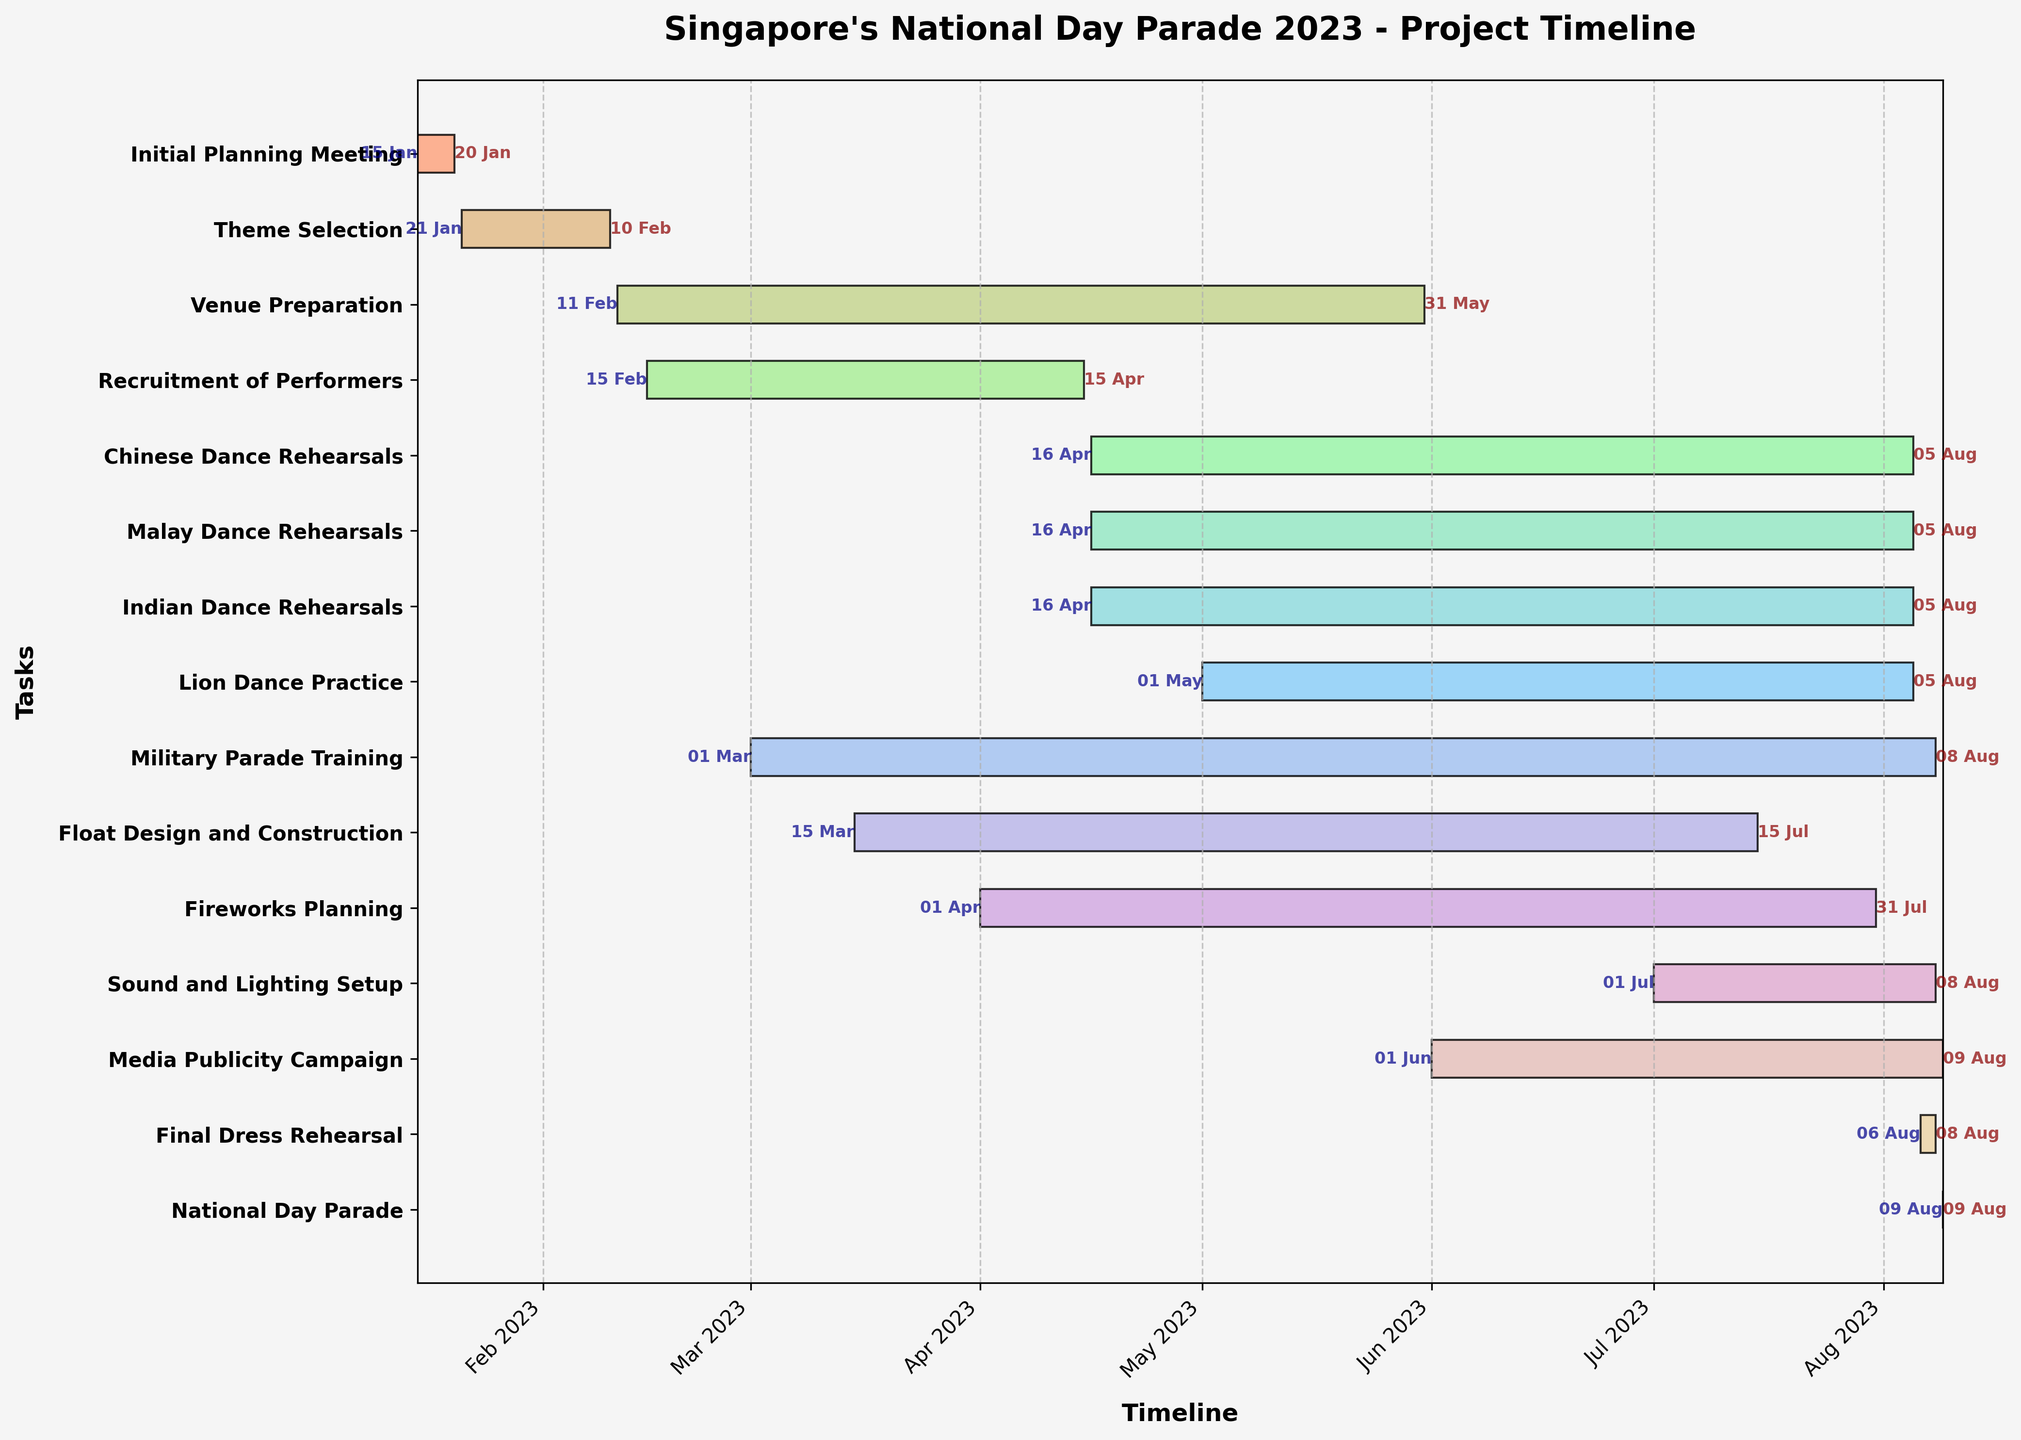What is the title of the Gantt chart? The title is usually displayed at the top of the chart. In this case, it reads "Singapore's National Day Parade 2023 - Project Timeline"
Answer: Singapore's National Day Parade 2023 - Project Timeline When does the Venue Preparation start and end? By looking at the Venue Preparation task on the y-axis, moving horizontally to the left and right edges of the bar, we can see the start and end dates. The start date is noted on the left side of the bar, and the end date on the right side.
Answer: Starts on 11 Feb, ends on 31 May Which task has the longest duration? To determine the task with the longest duration, we need to find the widest bar on the chart. "Venue Preparation" appears to be the widest.
Answer: Venue Preparation What is the earliest task to start? By looking at all bars and their leftmost points, we can determine the earliest start date. "Initial Planning Meeting" starts the earliest.
Answer: Initial Planning Meeting How many rehearsals start on the same day? By identifying tasks that begin on the same date and listing them: Chinese Dance Rehearsals, Malay Dance Rehearsals, and Indian Dance Rehearsals all start on 16 Apr.
Answer: Three Which performance rehearsal has the shortest duration? Comparing the lengths of bars corresponding to the performance rehearsals, we see that the "Lion Dance Practice" starts later than the others but ends on the same day.
Answer: Lion Dance Practice When does media publicity campaign begin and end? By locating the "Media Publicity Campaign" task on the y-axis and noting the start and end dates displayed on the bar's left and right edges, respectively.
Answer: Starts on 1 Jun, ends on 9 Aug What's the difference in ending dates between Fireworks Planning and Float Design and Construction? Fireworks Planning ends on 31 Jul, and Float Design and Construction ends on 15 Jul. The difference between them is found by subtracting the earlier date from the later date.
Answer: 16 days Which task overlaps the most with the Venue Preparation task? Evaluating other tasks' start and end dates concerning the duration of Venue Preparation, "Recruitment of Performers" and "Float Design and Construction" overlap significantly, but "Military Parade Training" overlaps most substantially.
Answer: Military Parade Training What tasks are still ongoing one week before National Day? By checking tasks that haven’t finished by one week before National Day (i.e., 2 Aug), we can find Military Parade Training, Sound and Lighting Setup, Media Publicity Campaign, and Final Dress Rehearsal still ongoing.
Answer: Military Parade Training, Sound and Lighting Setup, Media Publicity Campaign, Final Dress Rehearsal 